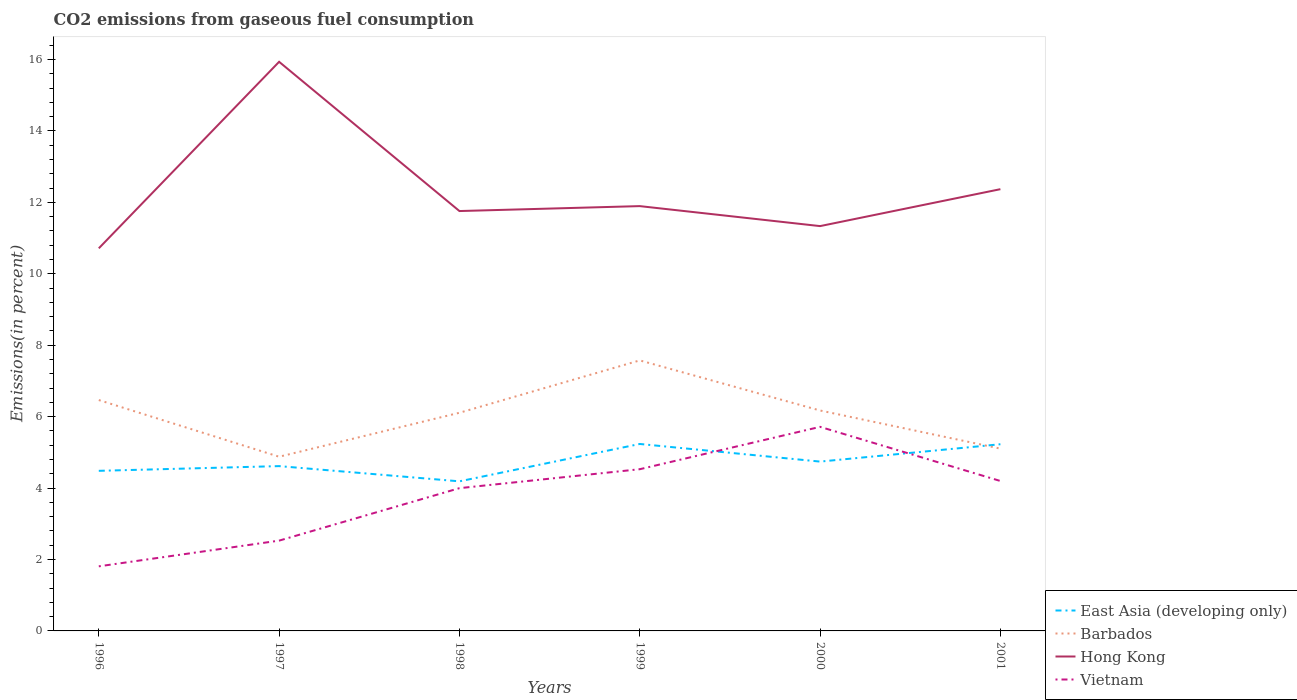How many different coloured lines are there?
Ensure brevity in your answer.  4. Across all years, what is the maximum total CO2 emitted in Hong Kong?
Offer a very short reply. 10.71. In which year was the total CO2 emitted in Barbados maximum?
Make the answer very short. 1997. What is the total total CO2 emitted in Barbados in the graph?
Give a very brief answer. -0.23. What is the difference between the highest and the second highest total CO2 emitted in Barbados?
Give a very brief answer. 2.7. Is the total CO2 emitted in Hong Kong strictly greater than the total CO2 emitted in East Asia (developing only) over the years?
Give a very brief answer. No. How many years are there in the graph?
Your response must be concise. 6. What is the difference between two consecutive major ticks on the Y-axis?
Keep it short and to the point. 2. Are the values on the major ticks of Y-axis written in scientific E-notation?
Your answer should be compact. No. Does the graph contain any zero values?
Ensure brevity in your answer.  No. Does the graph contain grids?
Ensure brevity in your answer.  No. What is the title of the graph?
Your response must be concise. CO2 emissions from gaseous fuel consumption. Does "Monaco" appear as one of the legend labels in the graph?
Make the answer very short. No. What is the label or title of the Y-axis?
Your answer should be very brief. Emissions(in percent). What is the Emissions(in percent) of East Asia (developing only) in 1996?
Give a very brief answer. 4.48. What is the Emissions(in percent) in Barbados in 1996?
Your answer should be very brief. 6.47. What is the Emissions(in percent) of Hong Kong in 1996?
Your answer should be very brief. 10.71. What is the Emissions(in percent) of Vietnam in 1996?
Offer a very short reply. 1.81. What is the Emissions(in percent) in East Asia (developing only) in 1997?
Make the answer very short. 4.62. What is the Emissions(in percent) of Barbados in 1997?
Your answer should be compact. 4.88. What is the Emissions(in percent) in Hong Kong in 1997?
Give a very brief answer. 15.94. What is the Emissions(in percent) of Vietnam in 1997?
Your answer should be very brief. 2.53. What is the Emissions(in percent) of East Asia (developing only) in 1998?
Ensure brevity in your answer.  4.19. What is the Emissions(in percent) in Barbados in 1998?
Make the answer very short. 6.11. What is the Emissions(in percent) in Hong Kong in 1998?
Give a very brief answer. 11.76. What is the Emissions(in percent) of Vietnam in 1998?
Keep it short and to the point. 4. What is the Emissions(in percent) in East Asia (developing only) in 1999?
Offer a terse response. 5.24. What is the Emissions(in percent) in Barbados in 1999?
Your answer should be compact. 7.58. What is the Emissions(in percent) in Hong Kong in 1999?
Ensure brevity in your answer.  11.9. What is the Emissions(in percent) of Vietnam in 1999?
Provide a succinct answer. 4.53. What is the Emissions(in percent) of East Asia (developing only) in 2000?
Offer a terse response. 4.74. What is the Emissions(in percent) of Barbados in 2000?
Make the answer very short. 6.17. What is the Emissions(in percent) in Hong Kong in 2000?
Your response must be concise. 11.34. What is the Emissions(in percent) of Vietnam in 2000?
Offer a very short reply. 5.71. What is the Emissions(in percent) of East Asia (developing only) in 2001?
Ensure brevity in your answer.  5.23. What is the Emissions(in percent) in Barbados in 2001?
Give a very brief answer. 5.11. What is the Emissions(in percent) of Hong Kong in 2001?
Ensure brevity in your answer.  12.37. What is the Emissions(in percent) of Vietnam in 2001?
Offer a very short reply. 4.2. Across all years, what is the maximum Emissions(in percent) in East Asia (developing only)?
Offer a terse response. 5.24. Across all years, what is the maximum Emissions(in percent) of Barbados?
Offer a terse response. 7.58. Across all years, what is the maximum Emissions(in percent) of Hong Kong?
Your answer should be very brief. 15.94. Across all years, what is the maximum Emissions(in percent) in Vietnam?
Your answer should be very brief. 5.71. Across all years, what is the minimum Emissions(in percent) of East Asia (developing only)?
Provide a short and direct response. 4.19. Across all years, what is the minimum Emissions(in percent) of Barbados?
Give a very brief answer. 4.88. Across all years, what is the minimum Emissions(in percent) of Hong Kong?
Provide a short and direct response. 10.71. Across all years, what is the minimum Emissions(in percent) of Vietnam?
Provide a short and direct response. 1.81. What is the total Emissions(in percent) of East Asia (developing only) in the graph?
Keep it short and to the point. 28.49. What is the total Emissions(in percent) in Barbados in the graph?
Your answer should be compact. 36.31. What is the total Emissions(in percent) in Hong Kong in the graph?
Provide a short and direct response. 74.01. What is the total Emissions(in percent) of Vietnam in the graph?
Keep it short and to the point. 22.78. What is the difference between the Emissions(in percent) in East Asia (developing only) in 1996 and that in 1997?
Keep it short and to the point. -0.13. What is the difference between the Emissions(in percent) in Barbados in 1996 and that in 1997?
Ensure brevity in your answer.  1.59. What is the difference between the Emissions(in percent) of Hong Kong in 1996 and that in 1997?
Offer a very short reply. -5.22. What is the difference between the Emissions(in percent) of Vietnam in 1996 and that in 1997?
Give a very brief answer. -0.72. What is the difference between the Emissions(in percent) of East Asia (developing only) in 1996 and that in 1998?
Ensure brevity in your answer.  0.29. What is the difference between the Emissions(in percent) of Barbados in 1996 and that in 1998?
Your answer should be very brief. 0.36. What is the difference between the Emissions(in percent) of Hong Kong in 1996 and that in 1998?
Provide a succinct answer. -1.04. What is the difference between the Emissions(in percent) of Vietnam in 1996 and that in 1998?
Your response must be concise. -2.19. What is the difference between the Emissions(in percent) in East Asia (developing only) in 1996 and that in 1999?
Provide a succinct answer. -0.75. What is the difference between the Emissions(in percent) in Barbados in 1996 and that in 1999?
Your response must be concise. -1.11. What is the difference between the Emissions(in percent) of Hong Kong in 1996 and that in 1999?
Your answer should be very brief. -1.18. What is the difference between the Emissions(in percent) in Vietnam in 1996 and that in 1999?
Offer a terse response. -2.72. What is the difference between the Emissions(in percent) of East Asia (developing only) in 1996 and that in 2000?
Ensure brevity in your answer.  -0.26. What is the difference between the Emissions(in percent) of Barbados in 1996 and that in 2000?
Make the answer very short. 0.29. What is the difference between the Emissions(in percent) of Hong Kong in 1996 and that in 2000?
Offer a very short reply. -0.62. What is the difference between the Emissions(in percent) of Vietnam in 1996 and that in 2000?
Your response must be concise. -3.91. What is the difference between the Emissions(in percent) in East Asia (developing only) in 1996 and that in 2001?
Provide a succinct answer. -0.74. What is the difference between the Emissions(in percent) in Barbados in 1996 and that in 2001?
Ensure brevity in your answer.  1.36. What is the difference between the Emissions(in percent) of Hong Kong in 1996 and that in 2001?
Your answer should be compact. -1.66. What is the difference between the Emissions(in percent) of Vietnam in 1996 and that in 2001?
Your response must be concise. -2.39. What is the difference between the Emissions(in percent) in East Asia (developing only) in 1997 and that in 1998?
Your response must be concise. 0.43. What is the difference between the Emissions(in percent) in Barbados in 1997 and that in 1998?
Provide a short and direct response. -1.23. What is the difference between the Emissions(in percent) in Hong Kong in 1997 and that in 1998?
Your response must be concise. 4.18. What is the difference between the Emissions(in percent) of Vietnam in 1997 and that in 1998?
Provide a succinct answer. -1.47. What is the difference between the Emissions(in percent) in East Asia (developing only) in 1997 and that in 1999?
Give a very brief answer. -0.62. What is the difference between the Emissions(in percent) of Barbados in 1997 and that in 1999?
Your answer should be compact. -2.7. What is the difference between the Emissions(in percent) in Hong Kong in 1997 and that in 1999?
Provide a succinct answer. 4.04. What is the difference between the Emissions(in percent) of East Asia (developing only) in 1997 and that in 2000?
Provide a succinct answer. -0.13. What is the difference between the Emissions(in percent) in Barbados in 1997 and that in 2000?
Ensure brevity in your answer.  -1.29. What is the difference between the Emissions(in percent) of Hong Kong in 1997 and that in 2000?
Your answer should be very brief. 4.6. What is the difference between the Emissions(in percent) in Vietnam in 1997 and that in 2000?
Provide a short and direct response. -3.19. What is the difference between the Emissions(in percent) in East Asia (developing only) in 1997 and that in 2001?
Your response must be concise. -0.61. What is the difference between the Emissions(in percent) of Barbados in 1997 and that in 2001?
Keep it short and to the point. -0.23. What is the difference between the Emissions(in percent) of Hong Kong in 1997 and that in 2001?
Offer a terse response. 3.57. What is the difference between the Emissions(in percent) of Vietnam in 1997 and that in 2001?
Provide a succinct answer. -1.67. What is the difference between the Emissions(in percent) of East Asia (developing only) in 1998 and that in 1999?
Offer a very short reply. -1.05. What is the difference between the Emissions(in percent) of Barbados in 1998 and that in 1999?
Your answer should be very brief. -1.47. What is the difference between the Emissions(in percent) in Hong Kong in 1998 and that in 1999?
Offer a very short reply. -0.14. What is the difference between the Emissions(in percent) in Vietnam in 1998 and that in 1999?
Give a very brief answer. -0.53. What is the difference between the Emissions(in percent) in East Asia (developing only) in 1998 and that in 2000?
Give a very brief answer. -0.55. What is the difference between the Emissions(in percent) in Barbados in 1998 and that in 2000?
Your response must be concise. -0.06. What is the difference between the Emissions(in percent) of Hong Kong in 1998 and that in 2000?
Provide a succinct answer. 0.42. What is the difference between the Emissions(in percent) of Vietnam in 1998 and that in 2000?
Your answer should be very brief. -1.72. What is the difference between the Emissions(in percent) of East Asia (developing only) in 1998 and that in 2001?
Your response must be concise. -1.04. What is the difference between the Emissions(in percent) in Barbados in 1998 and that in 2001?
Your response must be concise. 1. What is the difference between the Emissions(in percent) of Hong Kong in 1998 and that in 2001?
Your answer should be compact. -0.61. What is the difference between the Emissions(in percent) in Vietnam in 1998 and that in 2001?
Provide a succinct answer. -0.2. What is the difference between the Emissions(in percent) in East Asia (developing only) in 1999 and that in 2000?
Your response must be concise. 0.49. What is the difference between the Emissions(in percent) in Barbados in 1999 and that in 2000?
Provide a succinct answer. 1.4. What is the difference between the Emissions(in percent) in Hong Kong in 1999 and that in 2000?
Your answer should be compact. 0.56. What is the difference between the Emissions(in percent) of Vietnam in 1999 and that in 2000?
Provide a short and direct response. -1.19. What is the difference between the Emissions(in percent) of East Asia (developing only) in 1999 and that in 2001?
Make the answer very short. 0.01. What is the difference between the Emissions(in percent) of Barbados in 1999 and that in 2001?
Offer a very short reply. 2.47. What is the difference between the Emissions(in percent) of Hong Kong in 1999 and that in 2001?
Your response must be concise. -0.47. What is the difference between the Emissions(in percent) of Vietnam in 1999 and that in 2001?
Keep it short and to the point. 0.33. What is the difference between the Emissions(in percent) in East Asia (developing only) in 2000 and that in 2001?
Your response must be concise. -0.49. What is the difference between the Emissions(in percent) of Barbados in 2000 and that in 2001?
Make the answer very short. 1.07. What is the difference between the Emissions(in percent) of Hong Kong in 2000 and that in 2001?
Offer a very short reply. -1.03. What is the difference between the Emissions(in percent) of Vietnam in 2000 and that in 2001?
Provide a succinct answer. 1.52. What is the difference between the Emissions(in percent) of East Asia (developing only) in 1996 and the Emissions(in percent) of Barbados in 1997?
Make the answer very short. -0.39. What is the difference between the Emissions(in percent) in East Asia (developing only) in 1996 and the Emissions(in percent) in Hong Kong in 1997?
Offer a very short reply. -11.45. What is the difference between the Emissions(in percent) of East Asia (developing only) in 1996 and the Emissions(in percent) of Vietnam in 1997?
Offer a very short reply. 1.95. What is the difference between the Emissions(in percent) in Barbados in 1996 and the Emissions(in percent) in Hong Kong in 1997?
Keep it short and to the point. -9.47. What is the difference between the Emissions(in percent) of Barbados in 1996 and the Emissions(in percent) of Vietnam in 1997?
Your response must be concise. 3.94. What is the difference between the Emissions(in percent) in Hong Kong in 1996 and the Emissions(in percent) in Vietnam in 1997?
Ensure brevity in your answer.  8.19. What is the difference between the Emissions(in percent) of East Asia (developing only) in 1996 and the Emissions(in percent) of Barbados in 1998?
Provide a succinct answer. -1.63. What is the difference between the Emissions(in percent) of East Asia (developing only) in 1996 and the Emissions(in percent) of Hong Kong in 1998?
Offer a very short reply. -7.27. What is the difference between the Emissions(in percent) in East Asia (developing only) in 1996 and the Emissions(in percent) in Vietnam in 1998?
Offer a terse response. 0.49. What is the difference between the Emissions(in percent) of Barbados in 1996 and the Emissions(in percent) of Hong Kong in 1998?
Provide a short and direct response. -5.29. What is the difference between the Emissions(in percent) of Barbados in 1996 and the Emissions(in percent) of Vietnam in 1998?
Provide a succinct answer. 2.47. What is the difference between the Emissions(in percent) of Hong Kong in 1996 and the Emissions(in percent) of Vietnam in 1998?
Give a very brief answer. 6.72. What is the difference between the Emissions(in percent) in East Asia (developing only) in 1996 and the Emissions(in percent) in Barbados in 1999?
Offer a terse response. -3.09. What is the difference between the Emissions(in percent) of East Asia (developing only) in 1996 and the Emissions(in percent) of Hong Kong in 1999?
Keep it short and to the point. -7.41. What is the difference between the Emissions(in percent) of East Asia (developing only) in 1996 and the Emissions(in percent) of Vietnam in 1999?
Keep it short and to the point. -0.05. What is the difference between the Emissions(in percent) of Barbados in 1996 and the Emissions(in percent) of Hong Kong in 1999?
Your response must be concise. -5.43. What is the difference between the Emissions(in percent) of Barbados in 1996 and the Emissions(in percent) of Vietnam in 1999?
Provide a short and direct response. 1.94. What is the difference between the Emissions(in percent) of Hong Kong in 1996 and the Emissions(in percent) of Vietnam in 1999?
Your response must be concise. 6.19. What is the difference between the Emissions(in percent) in East Asia (developing only) in 1996 and the Emissions(in percent) in Barbados in 2000?
Provide a short and direct response. -1.69. What is the difference between the Emissions(in percent) of East Asia (developing only) in 1996 and the Emissions(in percent) of Hong Kong in 2000?
Make the answer very short. -6.85. What is the difference between the Emissions(in percent) in East Asia (developing only) in 1996 and the Emissions(in percent) in Vietnam in 2000?
Provide a succinct answer. -1.23. What is the difference between the Emissions(in percent) in Barbados in 1996 and the Emissions(in percent) in Hong Kong in 2000?
Your answer should be very brief. -4.87. What is the difference between the Emissions(in percent) in Barbados in 1996 and the Emissions(in percent) in Vietnam in 2000?
Provide a short and direct response. 0.75. What is the difference between the Emissions(in percent) of Hong Kong in 1996 and the Emissions(in percent) of Vietnam in 2000?
Your response must be concise. 5. What is the difference between the Emissions(in percent) of East Asia (developing only) in 1996 and the Emissions(in percent) of Barbados in 2001?
Keep it short and to the point. -0.62. What is the difference between the Emissions(in percent) of East Asia (developing only) in 1996 and the Emissions(in percent) of Hong Kong in 2001?
Offer a terse response. -7.89. What is the difference between the Emissions(in percent) in East Asia (developing only) in 1996 and the Emissions(in percent) in Vietnam in 2001?
Your answer should be compact. 0.28. What is the difference between the Emissions(in percent) of Barbados in 1996 and the Emissions(in percent) of Hong Kong in 2001?
Make the answer very short. -5.91. What is the difference between the Emissions(in percent) in Barbados in 1996 and the Emissions(in percent) in Vietnam in 2001?
Your answer should be compact. 2.27. What is the difference between the Emissions(in percent) in Hong Kong in 1996 and the Emissions(in percent) in Vietnam in 2001?
Make the answer very short. 6.52. What is the difference between the Emissions(in percent) of East Asia (developing only) in 1997 and the Emissions(in percent) of Barbados in 1998?
Your answer should be very brief. -1.49. What is the difference between the Emissions(in percent) in East Asia (developing only) in 1997 and the Emissions(in percent) in Hong Kong in 1998?
Provide a short and direct response. -7.14. What is the difference between the Emissions(in percent) in East Asia (developing only) in 1997 and the Emissions(in percent) in Vietnam in 1998?
Offer a very short reply. 0.62. What is the difference between the Emissions(in percent) in Barbados in 1997 and the Emissions(in percent) in Hong Kong in 1998?
Your answer should be compact. -6.88. What is the difference between the Emissions(in percent) in Barbados in 1997 and the Emissions(in percent) in Vietnam in 1998?
Offer a terse response. 0.88. What is the difference between the Emissions(in percent) of Hong Kong in 1997 and the Emissions(in percent) of Vietnam in 1998?
Provide a short and direct response. 11.94. What is the difference between the Emissions(in percent) in East Asia (developing only) in 1997 and the Emissions(in percent) in Barbados in 1999?
Offer a terse response. -2.96. What is the difference between the Emissions(in percent) of East Asia (developing only) in 1997 and the Emissions(in percent) of Hong Kong in 1999?
Offer a very short reply. -7.28. What is the difference between the Emissions(in percent) of East Asia (developing only) in 1997 and the Emissions(in percent) of Vietnam in 1999?
Your answer should be very brief. 0.09. What is the difference between the Emissions(in percent) in Barbados in 1997 and the Emissions(in percent) in Hong Kong in 1999?
Give a very brief answer. -7.02. What is the difference between the Emissions(in percent) of Barbados in 1997 and the Emissions(in percent) of Vietnam in 1999?
Your answer should be very brief. 0.35. What is the difference between the Emissions(in percent) of Hong Kong in 1997 and the Emissions(in percent) of Vietnam in 1999?
Make the answer very short. 11.41. What is the difference between the Emissions(in percent) of East Asia (developing only) in 1997 and the Emissions(in percent) of Barbados in 2000?
Your answer should be compact. -1.56. What is the difference between the Emissions(in percent) in East Asia (developing only) in 1997 and the Emissions(in percent) in Hong Kong in 2000?
Offer a very short reply. -6.72. What is the difference between the Emissions(in percent) in East Asia (developing only) in 1997 and the Emissions(in percent) in Vietnam in 2000?
Your answer should be very brief. -1.1. What is the difference between the Emissions(in percent) of Barbados in 1997 and the Emissions(in percent) of Hong Kong in 2000?
Give a very brief answer. -6.46. What is the difference between the Emissions(in percent) of Barbados in 1997 and the Emissions(in percent) of Vietnam in 2000?
Provide a short and direct response. -0.84. What is the difference between the Emissions(in percent) in Hong Kong in 1997 and the Emissions(in percent) in Vietnam in 2000?
Your answer should be very brief. 10.22. What is the difference between the Emissions(in percent) in East Asia (developing only) in 1997 and the Emissions(in percent) in Barbados in 2001?
Provide a short and direct response. -0.49. What is the difference between the Emissions(in percent) in East Asia (developing only) in 1997 and the Emissions(in percent) in Hong Kong in 2001?
Provide a short and direct response. -7.76. What is the difference between the Emissions(in percent) in East Asia (developing only) in 1997 and the Emissions(in percent) in Vietnam in 2001?
Offer a terse response. 0.42. What is the difference between the Emissions(in percent) in Barbados in 1997 and the Emissions(in percent) in Hong Kong in 2001?
Ensure brevity in your answer.  -7.49. What is the difference between the Emissions(in percent) of Barbados in 1997 and the Emissions(in percent) of Vietnam in 2001?
Offer a very short reply. 0.68. What is the difference between the Emissions(in percent) in Hong Kong in 1997 and the Emissions(in percent) in Vietnam in 2001?
Offer a terse response. 11.74. What is the difference between the Emissions(in percent) of East Asia (developing only) in 1998 and the Emissions(in percent) of Barbados in 1999?
Keep it short and to the point. -3.39. What is the difference between the Emissions(in percent) in East Asia (developing only) in 1998 and the Emissions(in percent) in Hong Kong in 1999?
Keep it short and to the point. -7.71. What is the difference between the Emissions(in percent) in East Asia (developing only) in 1998 and the Emissions(in percent) in Vietnam in 1999?
Provide a succinct answer. -0.34. What is the difference between the Emissions(in percent) of Barbados in 1998 and the Emissions(in percent) of Hong Kong in 1999?
Provide a succinct answer. -5.79. What is the difference between the Emissions(in percent) in Barbados in 1998 and the Emissions(in percent) in Vietnam in 1999?
Ensure brevity in your answer.  1.58. What is the difference between the Emissions(in percent) of Hong Kong in 1998 and the Emissions(in percent) of Vietnam in 1999?
Your answer should be very brief. 7.23. What is the difference between the Emissions(in percent) in East Asia (developing only) in 1998 and the Emissions(in percent) in Barbados in 2000?
Keep it short and to the point. -1.98. What is the difference between the Emissions(in percent) of East Asia (developing only) in 1998 and the Emissions(in percent) of Hong Kong in 2000?
Your response must be concise. -7.15. What is the difference between the Emissions(in percent) of East Asia (developing only) in 1998 and the Emissions(in percent) of Vietnam in 2000?
Give a very brief answer. -1.53. What is the difference between the Emissions(in percent) in Barbados in 1998 and the Emissions(in percent) in Hong Kong in 2000?
Provide a short and direct response. -5.23. What is the difference between the Emissions(in percent) of Barbados in 1998 and the Emissions(in percent) of Vietnam in 2000?
Provide a succinct answer. 0.39. What is the difference between the Emissions(in percent) of Hong Kong in 1998 and the Emissions(in percent) of Vietnam in 2000?
Offer a very short reply. 6.04. What is the difference between the Emissions(in percent) of East Asia (developing only) in 1998 and the Emissions(in percent) of Barbados in 2001?
Provide a succinct answer. -0.92. What is the difference between the Emissions(in percent) in East Asia (developing only) in 1998 and the Emissions(in percent) in Hong Kong in 2001?
Offer a terse response. -8.18. What is the difference between the Emissions(in percent) of East Asia (developing only) in 1998 and the Emissions(in percent) of Vietnam in 2001?
Give a very brief answer. -0.01. What is the difference between the Emissions(in percent) in Barbados in 1998 and the Emissions(in percent) in Hong Kong in 2001?
Keep it short and to the point. -6.26. What is the difference between the Emissions(in percent) of Barbados in 1998 and the Emissions(in percent) of Vietnam in 2001?
Provide a short and direct response. 1.91. What is the difference between the Emissions(in percent) in Hong Kong in 1998 and the Emissions(in percent) in Vietnam in 2001?
Make the answer very short. 7.56. What is the difference between the Emissions(in percent) in East Asia (developing only) in 1999 and the Emissions(in percent) in Barbados in 2000?
Your answer should be very brief. -0.94. What is the difference between the Emissions(in percent) of East Asia (developing only) in 1999 and the Emissions(in percent) of Hong Kong in 2000?
Offer a terse response. -6.1. What is the difference between the Emissions(in percent) in East Asia (developing only) in 1999 and the Emissions(in percent) in Vietnam in 2000?
Your answer should be very brief. -0.48. What is the difference between the Emissions(in percent) in Barbados in 1999 and the Emissions(in percent) in Hong Kong in 2000?
Your answer should be compact. -3.76. What is the difference between the Emissions(in percent) in Barbados in 1999 and the Emissions(in percent) in Vietnam in 2000?
Make the answer very short. 1.86. What is the difference between the Emissions(in percent) in Hong Kong in 1999 and the Emissions(in percent) in Vietnam in 2000?
Your answer should be very brief. 6.18. What is the difference between the Emissions(in percent) in East Asia (developing only) in 1999 and the Emissions(in percent) in Barbados in 2001?
Your answer should be compact. 0.13. What is the difference between the Emissions(in percent) of East Asia (developing only) in 1999 and the Emissions(in percent) of Hong Kong in 2001?
Make the answer very short. -7.14. What is the difference between the Emissions(in percent) in Barbados in 1999 and the Emissions(in percent) in Hong Kong in 2001?
Your answer should be compact. -4.8. What is the difference between the Emissions(in percent) of Barbados in 1999 and the Emissions(in percent) of Vietnam in 2001?
Offer a terse response. 3.38. What is the difference between the Emissions(in percent) in Hong Kong in 1999 and the Emissions(in percent) in Vietnam in 2001?
Give a very brief answer. 7.7. What is the difference between the Emissions(in percent) of East Asia (developing only) in 2000 and the Emissions(in percent) of Barbados in 2001?
Provide a succinct answer. -0.36. What is the difference between the Emissions(in percent) in East Asia (developing only) in 2000 and the Emissions(in percent) in Hong Kong in 2001?
Make the answer very short. -7.63. What is the difference between the Emissions(in percent) in East Asia (developing only) in 2000 and the Emissions(in percent) in Vietnam in 2001?
Your answer should be very brief. 0.54. What is the difference between the Emissions(in percent) in Barbados in 2000 and the Emissions(in percent) in Hong Kong in 2001?
Ensure brevity in your answer.  -6.2. What is the difference between the Emissions(in percent) in Barbados in 2000 and the Emissions(in percent) in Vietnam in 2001?
Your response must be concise. 1.97. What is the difference between the Emissions(in percent) of Hong Kong in 2000 and the Emissions(in percent) of Vietnam in 2001?
Make the answer very short. 7.14. What is the average Emissions(in percent) of East Asia (developing only) per year?
Provide a succinct answer. 4.75. What is the average Emissions(in percent) in Barbados per year?
Make the answer very short. 6.05. What is the average Emissions(in percent) in Hong Kong per year?
Provide a short and direct response. 12.34. What is the average Emissions(in percent) in Vietnam per year?
Your response must be concise. 3.8. In the year 1996, what is the difference between the Emissions(in percent) of East Asia (developing only) and Emissions(in percent) of Barbados?
Your answer should be compact. -1.98. In the year 1996, what is the difference between the Emissions(in percent) in East Asia (developing only) and Emissions(in percent) in Hong Kong?
Provide a succinct answer. -6.23. In the year 1996, what is the difference between the Emissions(in percent) of East Asia (developing only) and Emissions(in percent) of Vietnam?
Provide a short and direct response. 2.67. In the year 1996, what is the difference between the Emissions(in percent) in Barbados and Emissions(in percent) in Hong Kong?
Offer a very short reply. -4.25. In the year 1996, what is the difference between the Emissions(in percent) of Barbados and Emissions(in percent) of Vietnam?
Offer a very short reply. 4.66. In the year 1996, what is the difference between the Emissions(in percent) of Hong Kong and Emissions(in percent) of Vietnam?
Provide a short and direct response. 8.91. In the year 1997, what is the difference between the Emissions(in percent) in East Asia (developing only) and Emissions(in percent) in Barbados?
Make the answer very short. -0.26. In the year 1997, what is the difference between the Emissions(in percent) in East Asia (developing only) and Emissions(in percent) in Hong Kong?
Provide a short and direct response. -11.32. In the year 1997, what is the difference between the Emissions(in percent) in East Asia (developing only) and Emissions(in percent) in Vietnam?
Offer a terse response. 2.09. In the year 1997, what is the difference between the Emissions(in percent) of Barbados and Emissions(in percent) of Hong Kong?
Ensure brevity in your answer.  -11.06. In the year 1997, what is the difference between the Emissions(in percent) of Barbados and Emissions(in percent) of Vietnam?
Give a very brief answer. 2.35. In the year 1997, what is the difference between the Emissions(in percent) in Hong Kong and Emissions(in percent) in Vietnam?
Offer a very short reply. 13.41. In the year 1998, what is the difference between the Emissions(in percent) in East Asia (developing only) and Emissions(in percent) in Barbados?
Offer a terse response. -1.92. In the year 1998, what is the difference between the Emissions(in percent) of East Asia (developing only) and Emissions(in percent) of Hong Kong?
Make the answer very short. -7.57. In the year 1998, what is the difference between the Emissions(in percent) in East Asia (developing only) and Emissions(in percent) in Vietnam?
Provide a succinct answer. 0.19. In the year 1998, what is the difference between the Emissions(in percent) in Barbados and Emissions(in percent) in Hong Kong?
Keep it short and to the point. -5.65. In the year 1998, what is the difference between the Emissions(in percent) of Barbados and Emissions(in percent) of Vietnam?
Your response must be concise. 2.11. In the year 1998, what is the difference between the Emissions(in percent) in Hong Kong and Emissions(in percent) in Vietnam?
Offer a terse response. 7.76. In the year 1999, what is the difference between the Emissions(in percent) of East Asia (developing only) and Emissions(in percent) of Barbados?
Provide a short and direct response. -2.34. In the year 1999, what is the difference between the Emissions(in percent) in East Asia (developing only) and Emissions(in percent) in Hong Kong?
Offer a terse response. -6.66. In the year 1999, what is the difference between the Emissions(in percent) in East Asia (developing only) and Emissions(in percent) in Vietnam?
Your response must be concise. 0.71. In the year 1999, what is the difference between the Emissions(in percent) in Barbados and Emissions(in percent) in Hong Kong?
Provide a succinct answer. -4.32. In the year 1999, what is the difference between the Emissions(in percent) in Barbados and Emissions(in percent) in Vietnam?
Provide a short and direct response. 3.05. In the year 1999, what is the difference between the Emissions(in percent) of Hong Kong and Emissions(in percent) of Vietnam?
Ensure brevity in your answer.  7.37. In the year 2000, what is the difference between the Emissions(in percent) of East Asia (developing only) and Emissions(in percent) of Barbados?
Provide a short and direct response. -1.43. In the year 2000, what is the difference between the Emissions(in percent) in East Asia (developing only) and Emissions(in percent) in Hong Kong?
Provide a succinct answer. -6.59. In the year 2000, what is the difference between the Emissions(in percent) in East Asia (developing only) and Emissions(in percent) in Vietnam?
Ensure brevity in your answer.  -0.97. In the year 2000, what is the difference between the Emissions(in percent) of Barbados and Emissions(in percent) of Hong Kong?
Your answer should be very brief. -5.16. In the year 2000, what is the difference between the Emissions(in percent) in Barbados and Emissions(in percent) in Vietnam?
Ensure brevity in your answer.  0.46. In the year 2000, what is the difference between the Emissions(in percent) of Hong Kong and Emissions(in percent) of Vietnam?
Offer a very short reply. 5.62. In the year 2001, what is the difference between the Emissions(in percent) of East Asia (developing only) and Emissions(in percent) of Barbados?
Keep it short and to the point. 0.12. In the year 2001, what is the difference between the Emissions(in percent) of East Asia (developing only) and Emissions(in percent) of Hong Kong?
Your answer should be compact. -7.14. In the year 2001, what is the difference between the Emissions(in percent) of East Asia (developing only) and Emissions(in percent) of Vietnam?
Provide a succinct answer. 1.03. In the year 2001, what is the difference between the Emissions(in percent) in Barbados and Emissions(in percent) in Hong Kong?
Offer a terse response. -7.27. In the year 2001, what is the difference between the Emissions(in percent) in Barbados and Emissions(in percent) in Vietnam?
Provide a short and direct response. 0.91. In the year 2001, what is the difference between the Emissions(in percent) of Hong Kong and Emissions(in percent) of Vietnam?
Provide a short and direct response. 8.17. What is the ratio of the Emissions(in percent) of East Asia (developing only) in 1996 to that in 1997?
Your response must be concise. 0.97. What is the ratio of the Emissions(in percent) in Barbados in 1996 to that in 1997?
Offer a very short reply. 1.33. What is the ratio of the Emissions(in percent) in Hong Kong in 1996 to that in 1997?
Offer a terse response. 0.67. What is the ratio of the Emissions(in percent) of Vietnam in 1996 to that in 1997?
Offer a terse response. 0.72. What is the ratio of the Emissions(in percent) in East Asia (developing only) in 1996 to that in 1998?
Offer a very short reply. 1.07. What is the ratio of the Emissions(in percent) in Barbados in 1996 to that in 1998?
Keep it short and to the point. 1.06. What is the ratio of the Emissions(in percent) in Hong Kong in 1996 to that in 1998?
Your answer should be very brief. 0.91. What is the ratio of the Emissions(in percent) of Vietnam in 1996 to that in 1998?
Give a very brief answer. 0.45. What is the ratio of the Emissions(in percent) of East Asia (developing only) in 1996 to that in 1999?
Offer a terse response. 0.86. What is the ratio of the Emissions(in percent) in Barbados in 1996 to that in 1999?
Ensure brevity in your answer.  0.85. What is the ratio of the Emissions(in percent) in Hong Kong in 1996 to that in 1999?
Provide a succinct answer. 0.9. What is the ratio of the Emissions(in percent) in Vietnam in 1996 to that in 1999?
Provide a succinct answer. 0.4. What is the ratio of the Emissions(in percent) of East Asia (developing only) in 1996 to that in 2000?
Provide a succinct answer. 0.95. What is the ratio of the Emissions(in percent) of Barbados in 1996 to that in 2000?
Make the answer very short. 1.05. What is the ratio of the Emissions(in percent) in Hong Kong in 1996 to that in 2000?
Give a very brief answer. 0.95. What is the ratio of the Emissions(in percent) in Vietnam in 1996 to that in 2000?
Offer a terse response. 0.32. What is the ratio of the Emissions(in percent) of East Asia (developing only) in 1996 to that in 2001?
Provide a short and direct response. 0.86. What is the ratio of the Emissions(in percent) in Barbados in 1996 to that in 2001?
Your response must be concise. 1.27. What is the ratio of the Emissions(in percent) of Hong Kong in 1996 to that in 2001?
Keep it short and to the point. 0.87. What is the ratio of the Emissions(in percent) in Vietnam in 1996 to that in 2001?
Offer a very short reply. 0.43. What is the ratio of the Emissions(in percent) of East Asia (developing only) in 1997 to that in 1998?
Your response must be concise. 1.1. What is the ratio of the Emissions(in percent) of Barbados in 1997 to that in 1998?
Ensure brevity in your answer.  0.8. What is the ratio of the Emissions(in percent) of Hong Kong in 1997 to that in 1998?
Ensure brevity in your answer.  1.36. What is the ratio of the Emissions(in percent) of Vietnam in 1997 to that in 1998?
Provide a succinct answer. 0.63. What is the ratio of the Emissions(in percent) of East Asia (developing only) in 1997 to that in 1999?
Your answer should be compact. 0.88. What is the ratio of the Emissions(in percent) in Barbados in 1997 to that in 1999?
Offer a very short reply. 0.64. What is the ratio of the Emissions(in percent) in Hong Kong in 1997 to that in 1999?
Make the answer very short. 1.34. What is the ratio of the Emissions(in percent) of Vietnam in 1997 to that in 1999?
Give a very brief answer. 0.56. What is the ratio of the Emissions(in percent) of East Asia (developing only) in 1997 to that in 2000?
Your answer should be very brief. 0.97. What is the ratio of the Emissions(in percent) in Barbados in 1997 to that in 2000?
Ensure brevity in your answer.  0.79. What is the ratio of the Emissions(in percent) in Hong Kong in 1997 to that in 2000?
Provide a short and direct response. 1.41. What is the ratio of the Emissions(in percent) of Vietnam in 1997 to that in 2000?
Keep it short and to the point. 0.44. What is the ratio of the Emissions(in percent) of East Asia (developing only) in 1997 to that in 2001?
Give a very brief answer. 0.88. What is the ratio of the Emissions(in percent) of Barbados in 1997 to that in 2001?
Provide a succinct answer. 0.96. What is the ratio of the Emissions(in percent) in Hong Kong in 1997 to that in 2001?
Keep it short and to the point. 1.29. What is the ratio of the Emissions(in percent) of Vietnam in 1997 to that in 2001?
Give a very brief answer. 0.6. What is the ratio of the Emissions(in percent) in East Asia (developing only) in 1998 to that in 1999?
Your response must be concise. 0.8. What is the ratio of the Emissions(in percent) of Barbados in 1998 to that in 1999?
Your answer should be compact. 0.81. What is the ratio of the Emissions(in percent) in Hong Kong in 1998 to that in 1999?
Make the answer very short. 0.99. What is the ratio of the Emissions(in percent) of Vietnam in 1998 to that in 1999?
Provide a short and direct response. 0.88. What is the ratio of the Emissions(in percent) in East Asia (developing only) in 1998 to that in 2000?
Offer a very short reply. 0.88. What is the ratio of the Emissions(in percent) of Hong Kong in 1998 to that in 2000?
Your answer should be very brief. 1.04. What is the ratio of the Emissions(in percent) in Vietnam in 1998 to that in 2000?
Give a very brief answer. 0.7. What is the ratio of the Emissions(in percent) in East Asia (developing only) in 1998 to that in 2001?
Offer a terse response. 0.8. What is the ratio of the Emissions(in percent) of Barbados in 1998 to that in 2001?
Give a very brief answer. 1.2. What is the ratio of the Emissions(in percent) in Hong Kong in 1998 to that in 2001?
Provide a short and direct response. 0.95. What is the ratio of the Emissions(in percent) in Vietnam in 1998 to that in 2001?
Your answer should be compact. 0.95. What is the ratio of the Emissions(in percent) in East Asia (developing only) in 1999 to that in 2000?
Provide a short and direct response. 1.1. What is the ratio of the Emissions(in percent) of Barbados in 1999 to that in 2000?
Offer a terse response. 1.23. What is the ratio of the Emissions(in percent) of Hong Kong in 1999 to that in 2000?
Offer a terse response. 1.05. What is the ratio of the Emissions(in percent) in Vietnam in 1999 to that in 2000?
Your response must be concise. 0.79. What is the ratio of the Emissions(in percent) in Barbados in 1999 to that in 2001?
Keep it short and to the point. 1.48. What is the ratio of the Emissions(in percent) of Hong Kong in 1999 to that in 2001?
Make the answer very short. 0.96. What is the ratio of the Emissions(in percent) of Vietnam in 1999 to that in 2001?
Provide a succinct answer. 1.08. What is the ratio of the Emissions(in percent) of East Asia (developing only) in 2000 to that in 2001?
Give a very brief answer. 0.91. What is the ratio of the Emissions(in percent) in Barbados in 2000 to that in 2001?
Your answer should be compact. 1.21. What is the ratio of the Emissions(in percent) of Hong Kong in 2000 to that in 2001?
Give a very brief answer. 0.92. What is the ratio of the Emissions(in percent) of Vietnam in 2000 to that in 2001?
Offer a very short reply. 1.36. What is the difference between the highest and the second highest Emissions(in percent) in East Asia (developing only)?
Provide a short and direct response. 0.01. What is the difference between the highest and the second highest Emissions(in percent) in Barbados?
Offer a terse response. 1.11. What is the difference between the highest and the second highest Emissions(in percent) of Hong Kong?
Give a very brief answer. 3.57. What is the difference between the highest and the second highest Emissions(in percent) in Vietnam?
Your answer should be very brief. 1.19. What is the difference between the highest and the lowest Emissions(in percent) in East Asia (developing only)?
Your answer should be compact. 1.05. What is the difference between the highest and the lowest Emissions(in percent) of Barbados?
Ensure brevity in your answer.  2.7. What is the difference between the highest and the lowest Emissions(in percent) of Hong Kong?
Give a very brief answer. 5.22. What is the difference between the highest and the lowest Emissions(in percent) in Vietnam?
Provide a short and direct response. 3.91. 